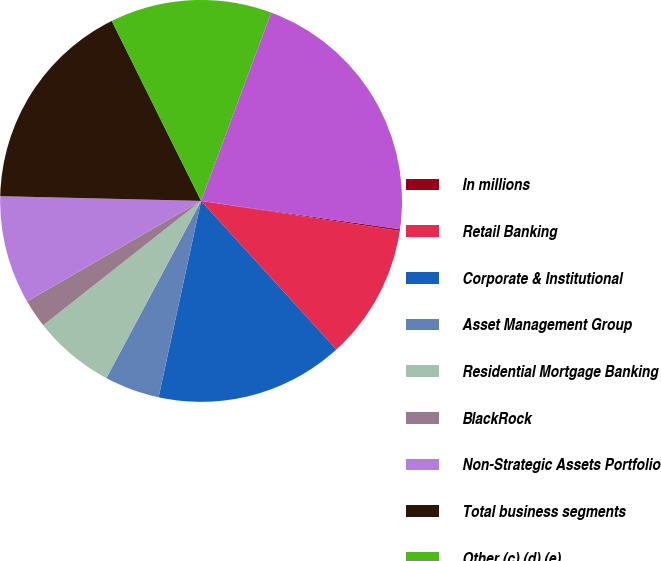Convert chart to OTSL. <chart><loc_0><loc_0><loc_500><loc_500><pie_chart><fcel>In millions<fcel>Retail Banking<fcel>Corporate & Institutional<fcel>Asset Management Group<fcel>Residential Mortgage Banking<fcel>BlackRock<fcel>Non-Strategic Assets Portfolio<fcel>Total business segments<fcel>Other (c) (d) (e)<fcel>Total<nl><fcel>0.13%<fcel>10.86%<fcel>15.15%<fcel>4.42%<fcel>6.57%<fcel>2.28%<fcel>8.71%<fcel>17.29%<fcel>13.0%<fcel>21.58%<nl></chart> 